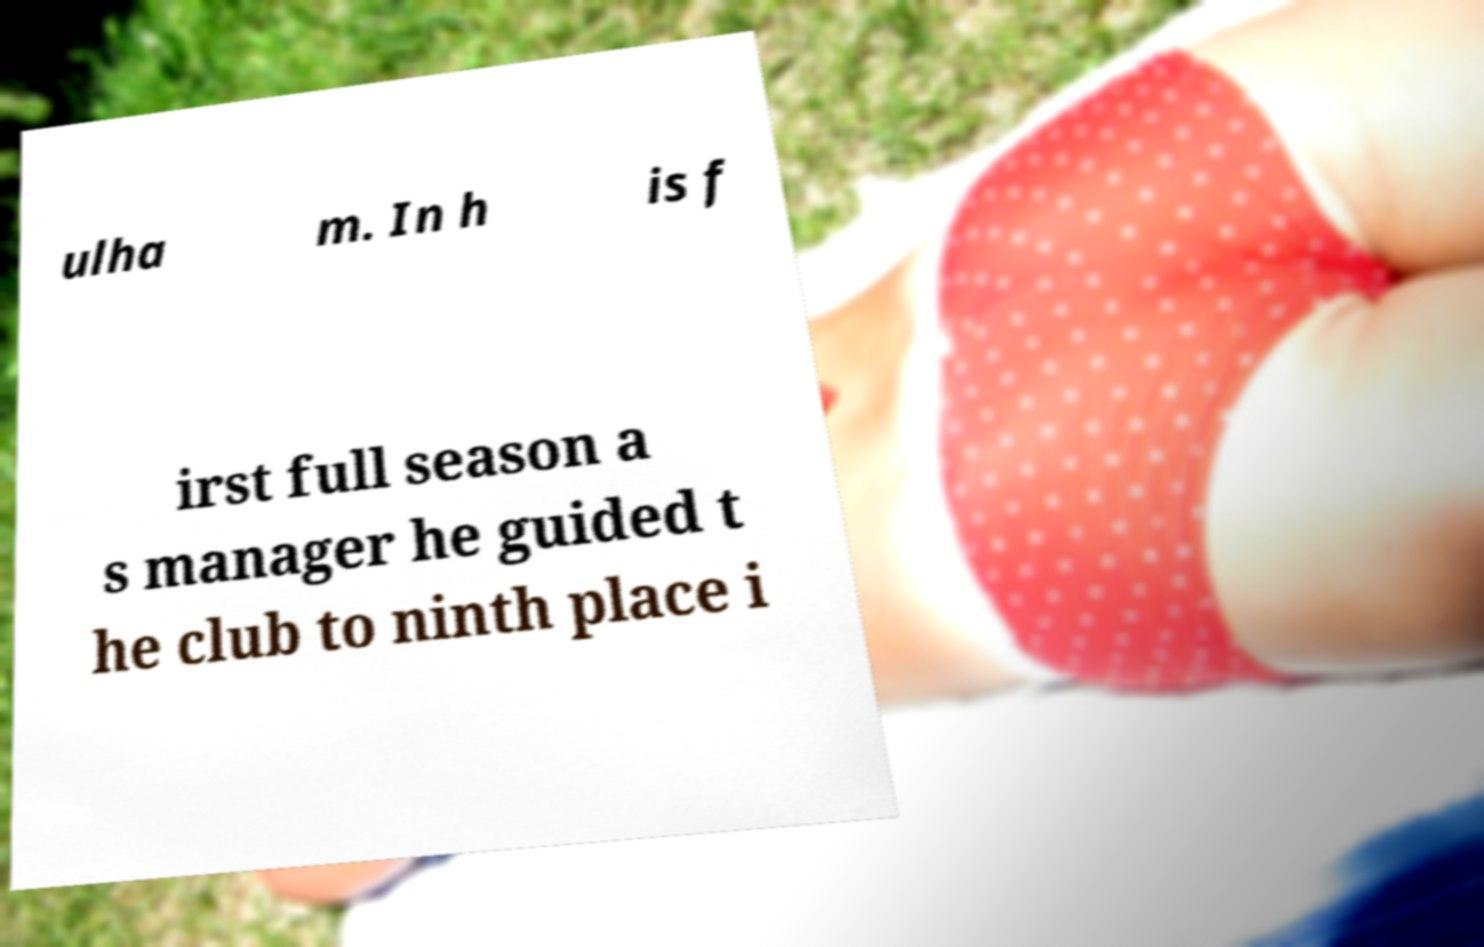Can you accurately transcribe the text from the provided image for me? ulha m. In h is f irst full season a s manager he guided t he club to ninth place i 